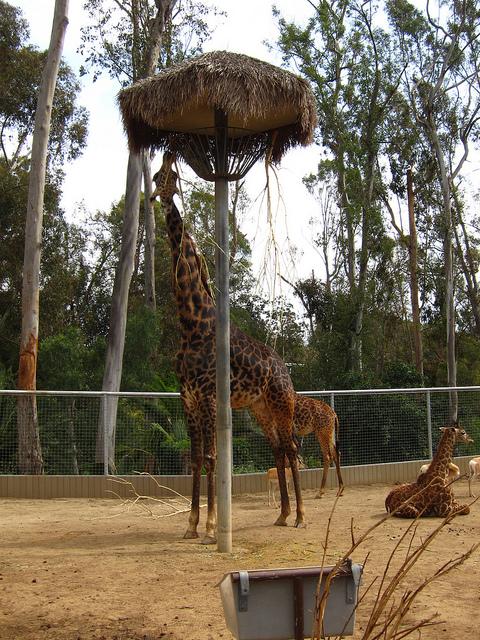What type of animal is shown?
Be succinct. Giraffe. Would a gerbil be able to access the food?
Be succinct. No. How many animals are here?
Write a very short answer. 3. Where are the giraffes?
Keep it brief. Zoo. 